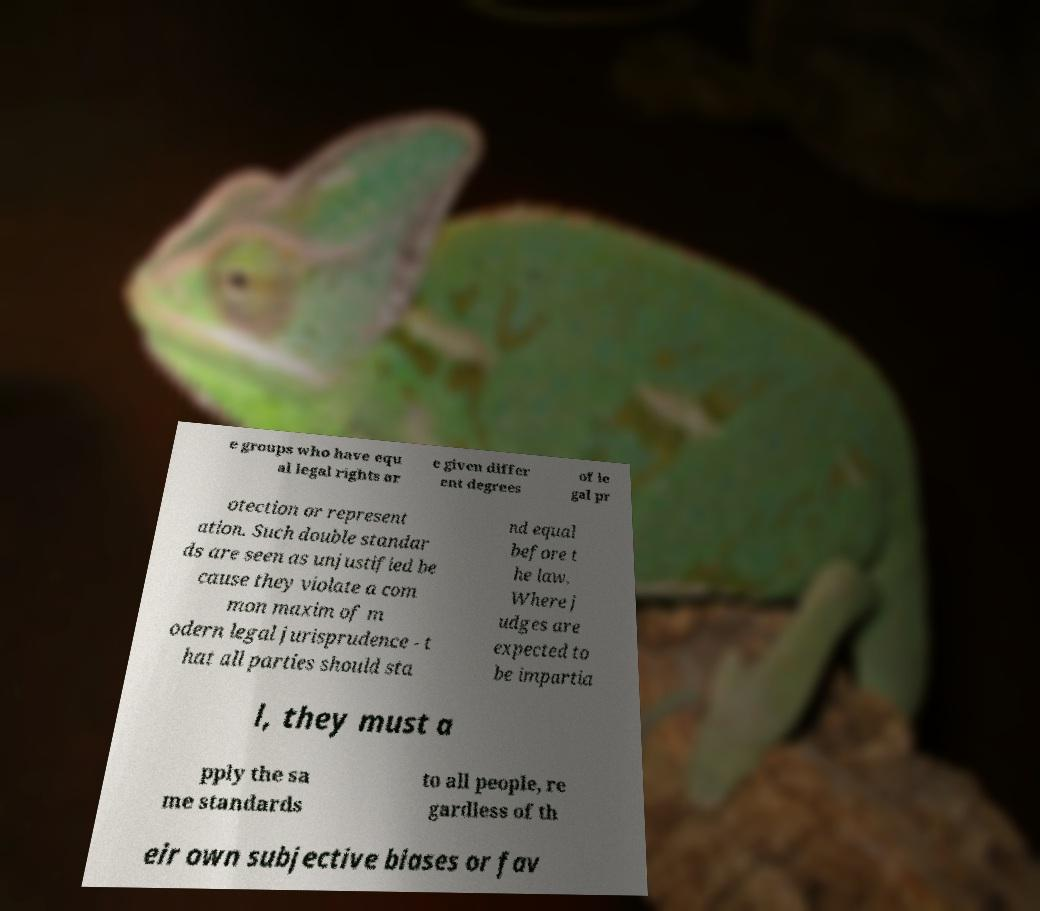I need the written content from this picture converted into text. Can you do that? e groups who have equ al legal rights ar e given differ ent degrees of le gal pr otection or represent ation. Such double standar ds are seen as unjustified be cause they violate a com mon maxim of m odern legal jurisprudence - t hat all parties should sta nd equal before t he law. Where j udges are expected to be impartia l, they must a pply the sa me standards to all people, re gardless of th eir own subjective biases or fav 